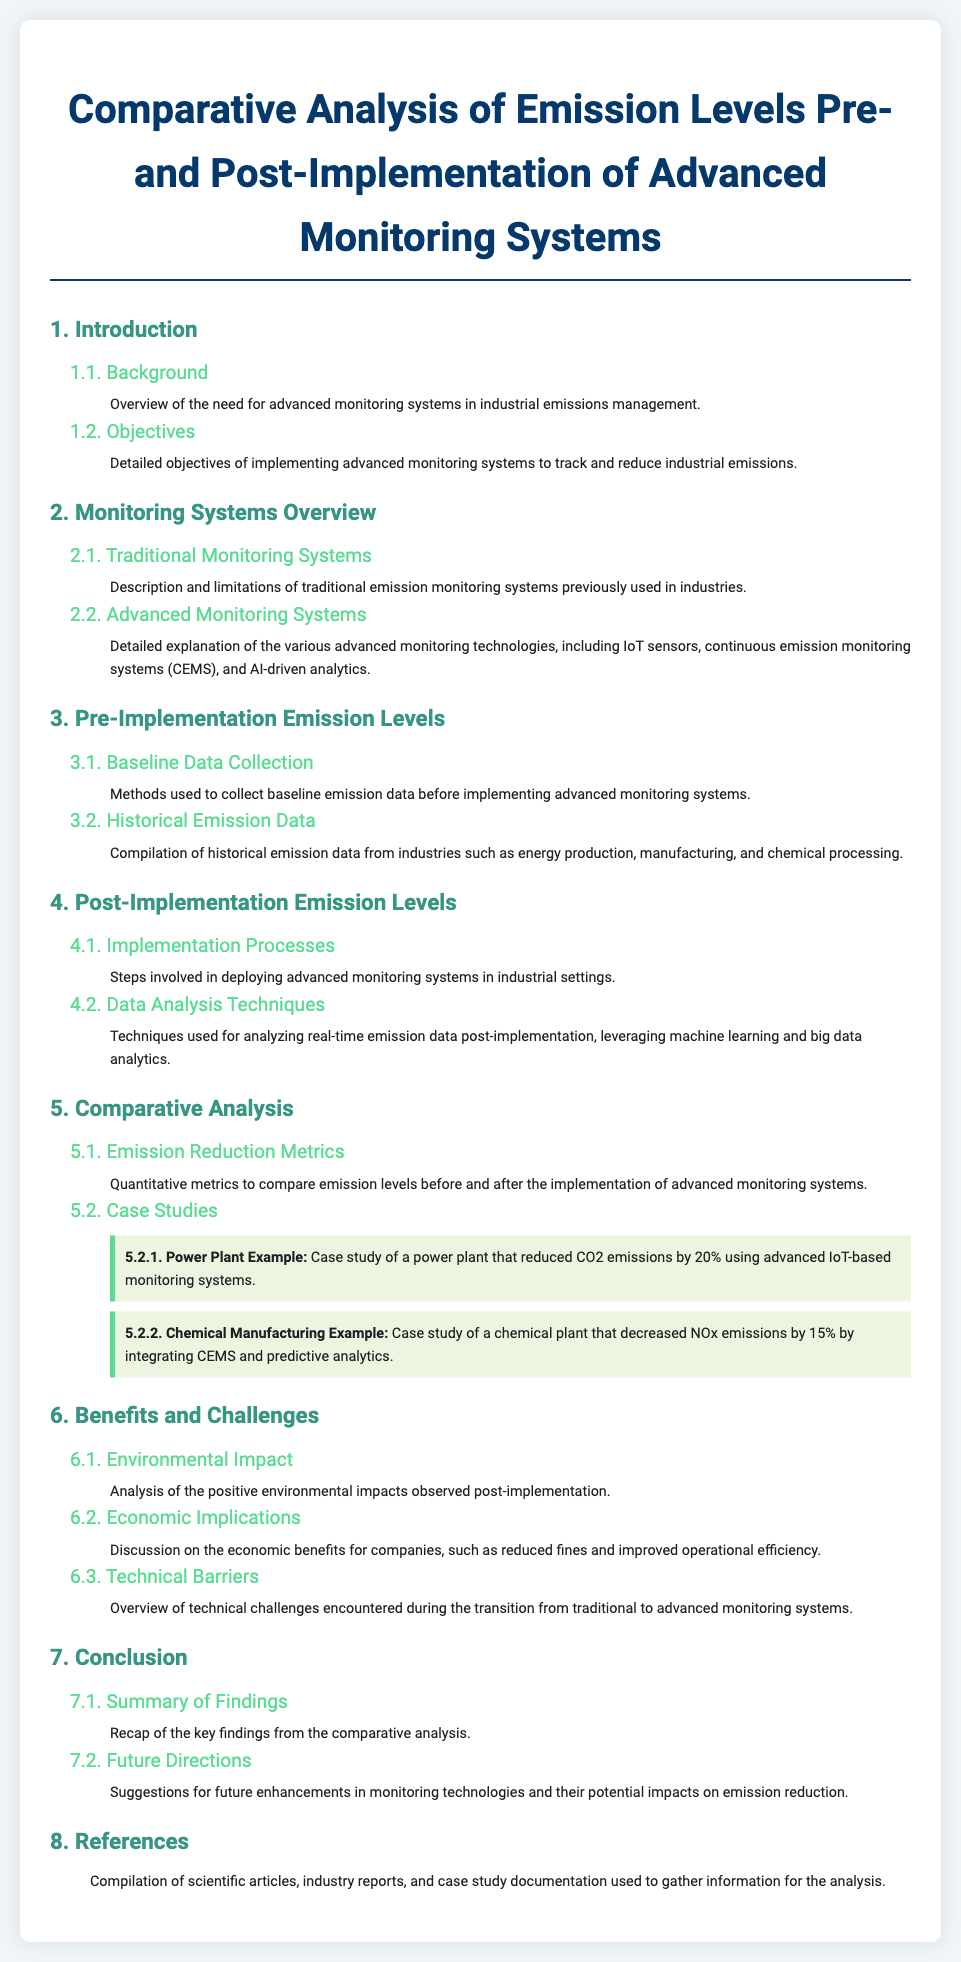What is the title of the document? The title is the main heading of the document, reflecting its focus on emission levels and monitoring systems.
Answer: Comparative Analysis of Emission Levels Pre- and Post-Implementation of Advanced Monitoring Systems What are the two prime objectives stated in the introduction? The objectives are outlined in the introduction as the goals of implementing monitoring systems for emission tracking and reduction.
Answer: Track and reduce industrial emissions What is a limitation of traditional monitoring systems? This information discusses what challenges traditional systems may have faced as compared to newer ones.
Answer: Limitations of traditional emission monitoring systems By what percentage did the power plant reduce CO2 emissions? This question refers to a specific case study included in the comparative analysis section.
Answer: 20% What advanced technologies are mentioned in the overview section? This question requires looking into the details about the types of technologies introduced for monitoring emissions.
Answer: IoT sensors, continuous emission monitoring systems, AI-driven analytics What notable benefit is highlighted in section 6.1? This question refers to positive outcomes of using advanced monitoring systems as discussed in that section.
Answer: Positive environmental impacts What type of data was compiled in section 3.2? This question examines the focus of the historical data collected before the implementation of new systems.
Answer: Historical emission data What does section 7.2 suggest for future work? The section discusses potential improvements and advancements in monitoring technologies.
Answer: Future enhancements in monitoring technologies What types of documents are listed in section 8? This question is about the nature of references included at the end of the document.
Answer: Scientific articles, industry reports, case study documentation 